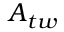<formula> <loc_0><loc_0><loc_500><loc_500>A _ { t w }</formula> 